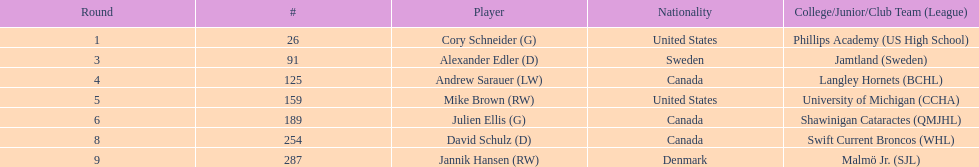What quantity of players have canada listed as their nationality? 3. 